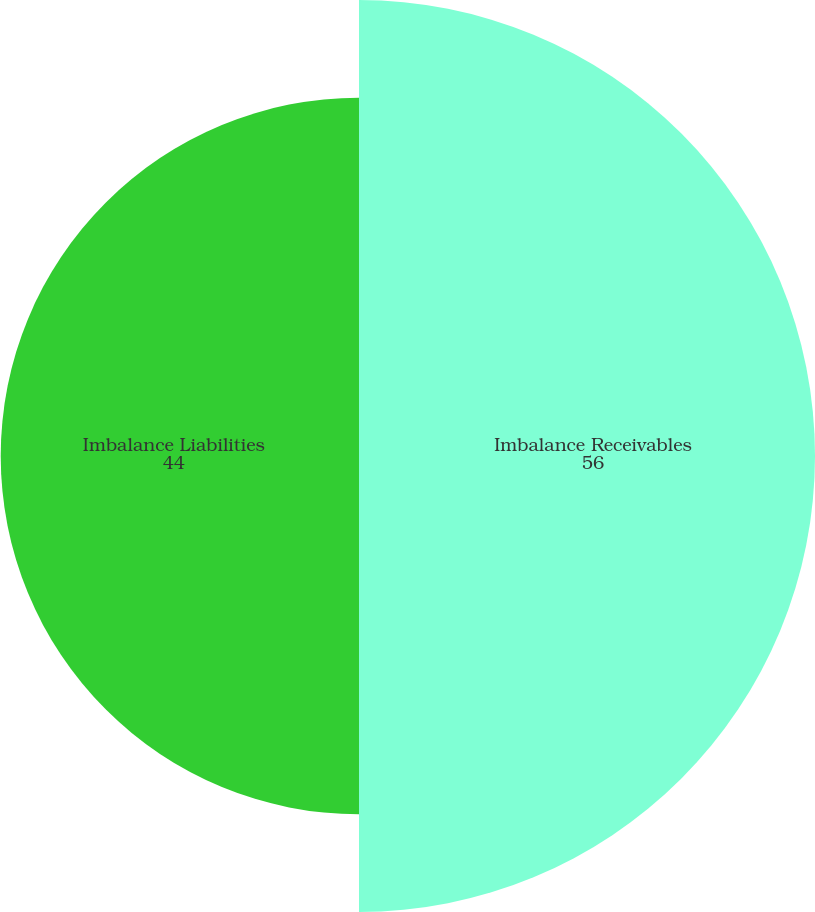Convert chart to OTSL. <chart><loc_0><loc_0><loc_500><loc_500><pie_chart><fcel>Imbalance Receivables<fcel>Imbalance Liabilities<nl><fcel>56.0%<fcel>44.0%<nl></chart> 